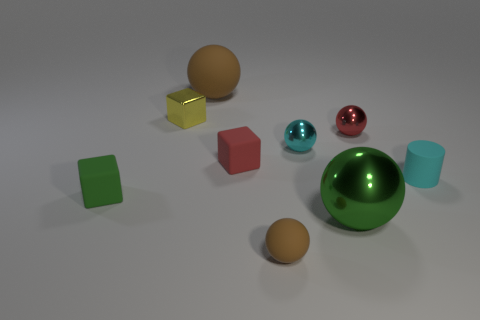Subtract all tiny matte blocks. How many blocks are left? 1 Add 1 small yellow objects. How many objects exist? 10 Subtract all green blocks. How many brown spheres are left? 2 Subtract all brown balls. How many balls are left? 3 Subtract 1 blocks. How many blocks are left? 2 Subtract all cylinders. How many objects are left? 8 Add 5 small gray metal blocks. How many small gray metal blocks exist? 5 Subtract 0 brown blocks. How many objects are left? 9 Subtract all yellow cylinders. Subtract all purple spheres. How many cylinders are left? 1 Subtract all small yellow metal cubes. Subtract all metal things. How many objects are left? 4 